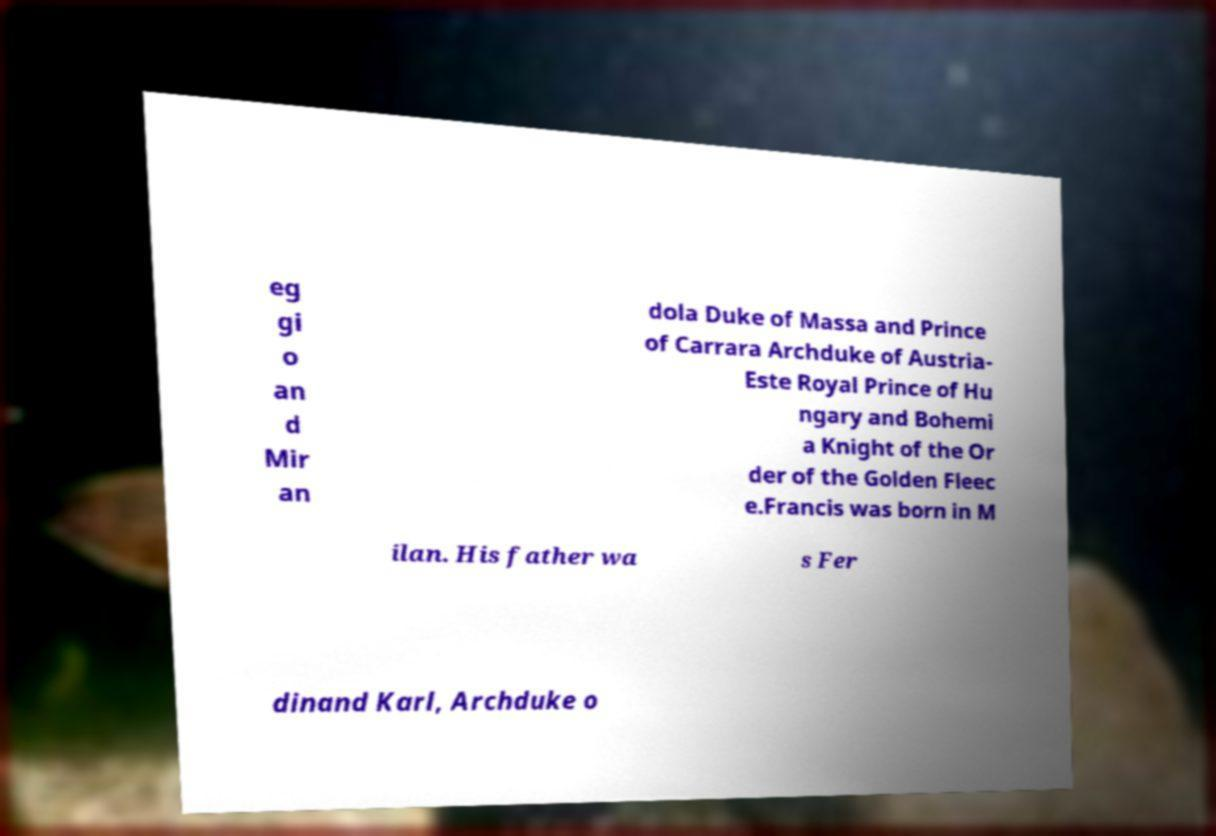Can you read and provide the text displayed in the image?This photo seems to have some interesting text. Can you extract and type it out for me? eg gi o an d Mir an dola Duke of Massa and Prince of Carrara Archduke of Austria- Este Royal Prince of Hu ngary and Bohemi a Knight of the Or der of the Golden Fleec e.Francis was born in M ilan. His father wa s Fer dinand Karl, Archduke o 